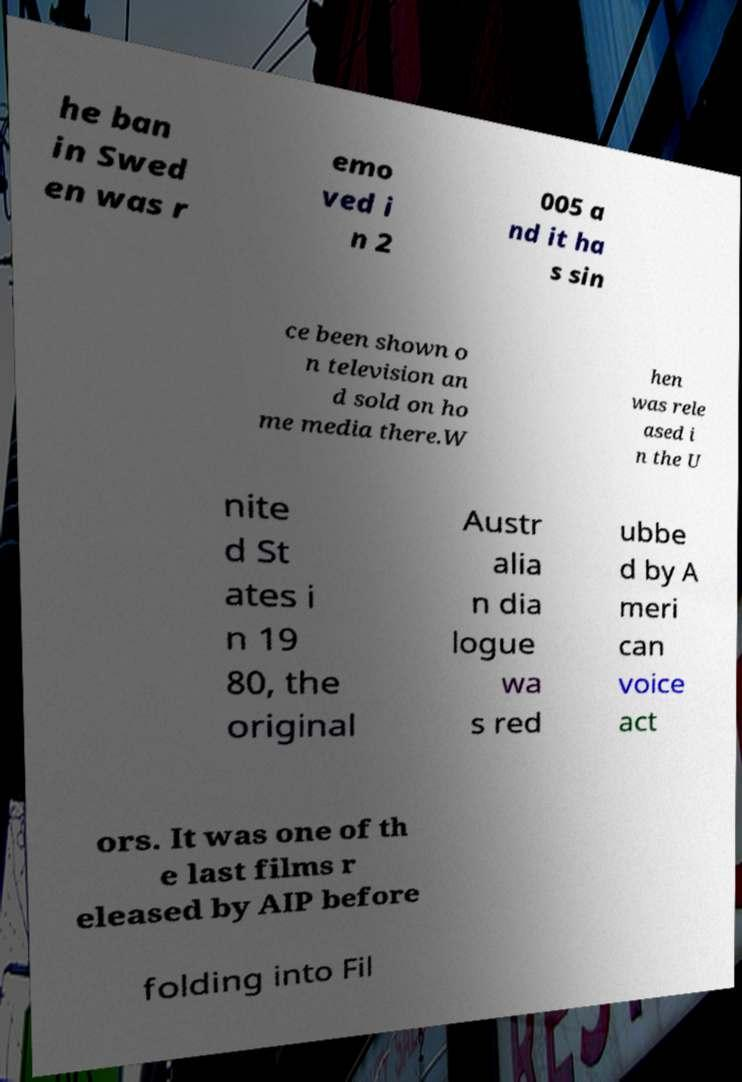Could you assist in decoding the text presented in this image and type it out clearly? he ban in Swed en was r emo ved i n 2 005 a nd it ha s sin ce been shown o n television an d sold on ho me media there.W hen was rele ased i n the U nite d St ates i n 19 80, the original Austr alia n dia logue wa s red ubbe d by A meri can voice act ors. It was one of th e last films r eleased by AIP before folding into Fil 